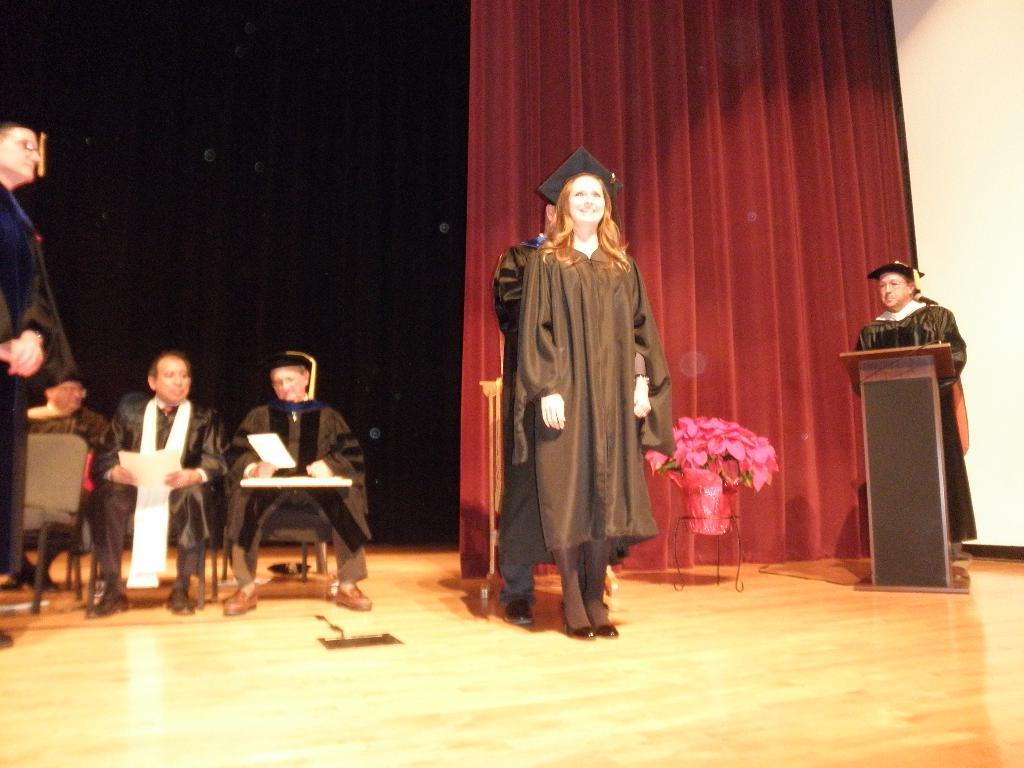Please provide a concise description of this image. In the image there are four persons standing in graduation dress and on the left side there are few persons standing and sitting on chairs, on the right side there is curtain on the back with a plant in front of it. 